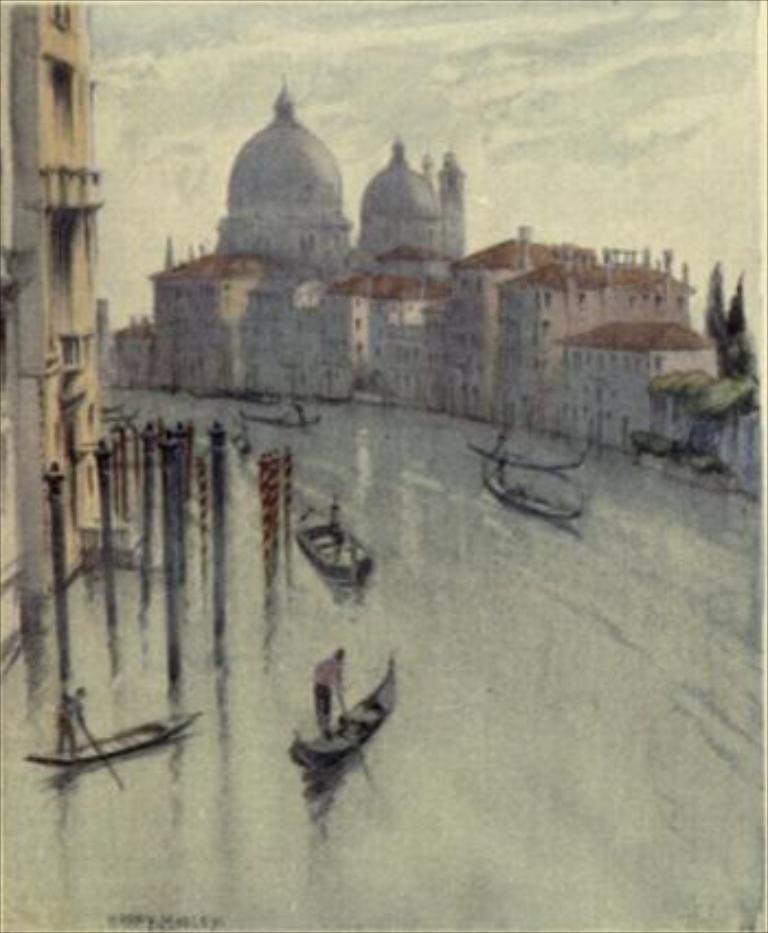Describe this image in one or two sentences. This is a image of the river where we can see there are some boats sailing, beside that there are some buildings. 